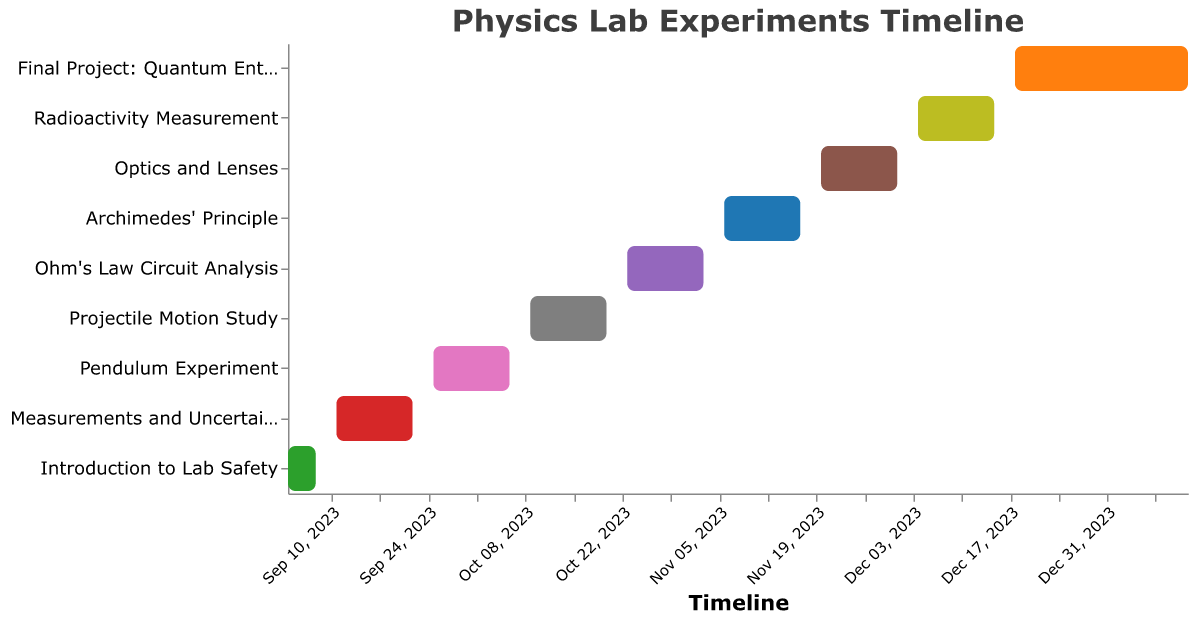What is the duration of the "Introduction to Lab Safety" task? The "Introduction to Lab Safety" task starts on 2023-09-04 and ends on 2023-09-08. The duration is the difference between the two dates. So, September 4th to September 8th is 5 days.
Answer: 5 days When does the "Final Project: Quantum Entanglement" task end? The "Final Project: Quantum Entanglement" task ends on 2024-01-12, as indicated by its end date in the chart.
Answer: 2024-01-12 Which lab experiment directly follows "Pendulum Experiment"? According to the timeline, "Pendulum Experiment" ends on 2023-10-06. The experiment that starts immediately after is "Projectile Motion Study" on 2023-10-09.
Answer: Projectile Motion Study How many experiments are conducted before "Ohm's Law Circuit Analysis"? The experiments before "Ohm's Law Circuit Analysis" are "Introduction to Lab Safety," "Measurements and Uncertainty," "Pendulum Experiment," and "Projectile Motion Study." There are four experiments in total.
Answer: 4 experiments Which task takes the longest duration to complete? By comparing the start and end dates, "Final Project: Quantum Entanglement" takes the longest to complete, from 2023-12-18 to 2024-01-12, which is 26 days.
Answer: Final Project: Quantum Entanglement Are there any lab experiments conducted in December? Yes, "Radioactivity Measurement" runs from 2023-12-04 to 2023-12-15, and "Final Project: Quantum Entanglement" starts on 2023-12-18.
Answer: Yes What task is performed after "Optics and Lenses"? "Optics and Lenses" ends on 2023-12-01, and "Radioactivity Measurement" starts on 2023-12-04.
Answer: Radioactivity Measurement How long does the "Measurements and Uncertainty" task last? The "Measurements and Uncertainty" task runs from 2023-09-11 to 2023-09-22. The duration is the difference between these dates, which is 12 days.
Answer: 12 days Compare the duration of the "Pendulum Experiment" and the "Archimedes' Principle" experiments. Which lasts longer? The "Pendulum Experiment" goes from 2023-09-25 to 2023-10-06, lasting 12 days. "Archimedes' Principle" runs from 2023-11-06 to 2023-11-17, lasting 12 days. Both last for the same amount of time.
Answer: Both What are the start and end dates of the fall semester experiment series? The first task "Introduction to Lab Safety" starts on 2023-09-04, and the last task "Final Project: Quantum Entanglement" ends on 2024-01-12.
Answer: 2023-09-04 to 2024-01-12 